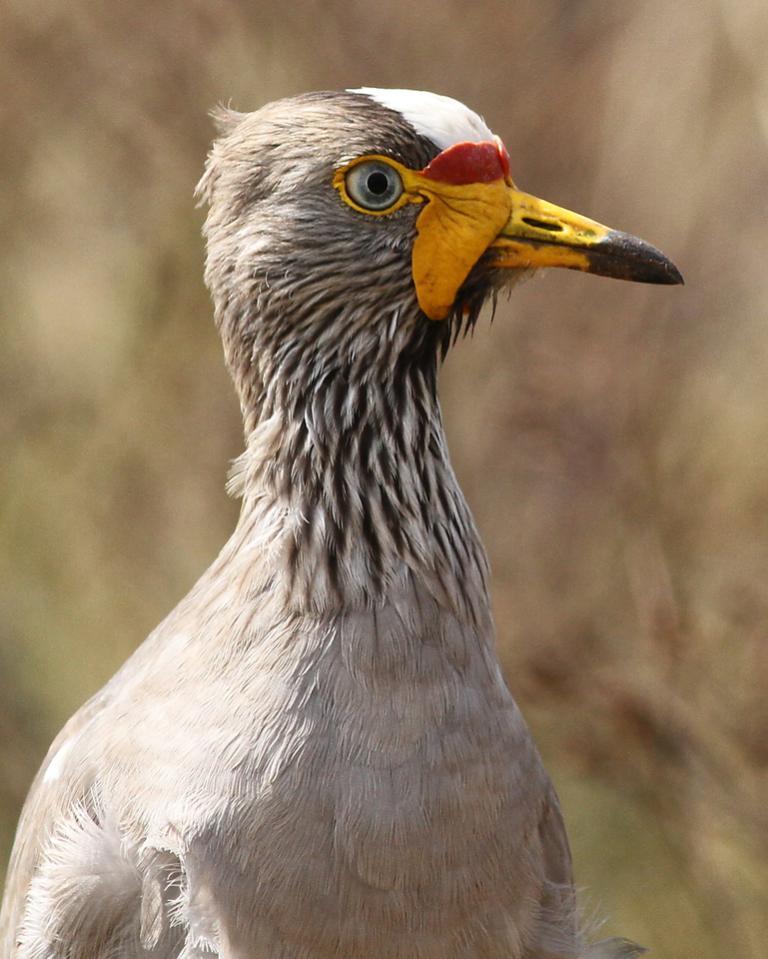Could you give a brief overview of what you see in this image? As we can see in the image in the front there is a white color bird and the background is blurred. 